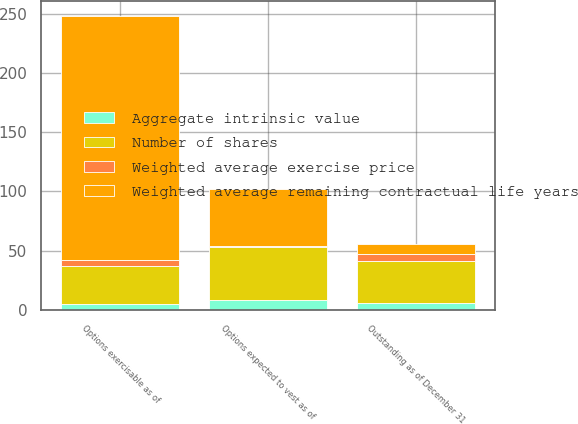<chart> <loc_0><loc_0><loc_500><loc_500><stacked_bar_chart><ecel><fcel>Outstanding as of December 31<fcel>Options exercisable as of<fcel>Options expected to vest as of<nl><fcel>Weighted average exercise price<fcel>6.2<fcel>4.7<fcel>1.5<nl><fcel>Number of shares<fcel>35.53<fcel>32.78<fcel>44.27<nl><fcel>Aggregate intrinsic value<fcel>5.6<fcel>4.7<fcel>8.5<nl><fcel>Weighted average remaining contractual life years<fcel>8.5<fcel>205.8<fcel>48<nl></chart> 